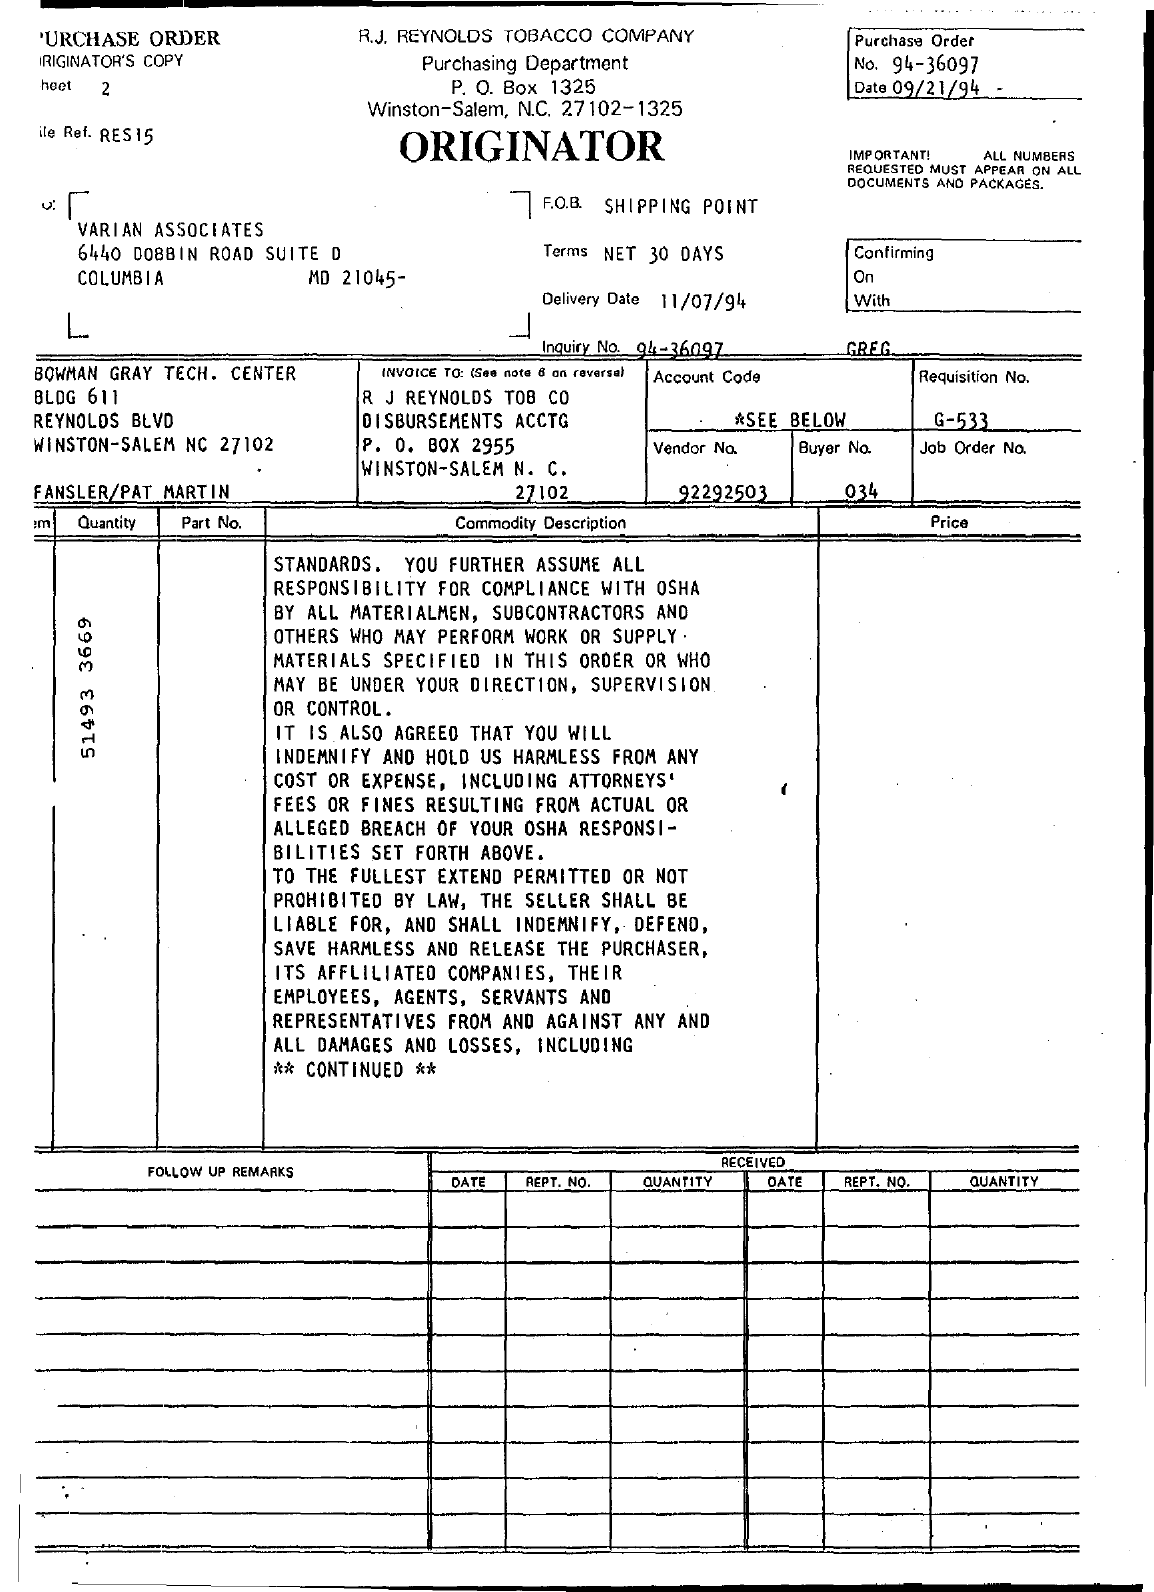Point out several critical features in this image. The purchase order number is 94-36097. The delivery date is on 11/07/94. The buyer number is 34. The purchase order date is September 21, 1994. The requisition number is G-533... 